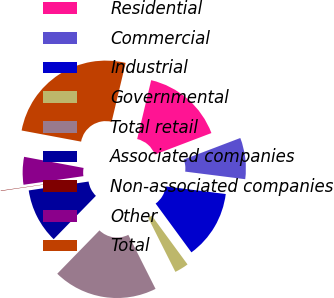Convert chart. <chart><loc_0><loc_0><loc_500><loc_500><pie_chart><fcel>Residential<fcel>Commercial<fcel>Industrial<fcel>Governmental<fcel>Total retail<fcel>Associated companies<fcel>Non-associated companies<fcel>Other<fcel>Total<nl><fcel>15.5%<fcel>7.79%<fcel>12.93%<fcel>2.65%<fcel>19.72%<fcel>10.36%<fcel>0.08%<fcel>5.22%<fcel>25.78%<nl></chart> 